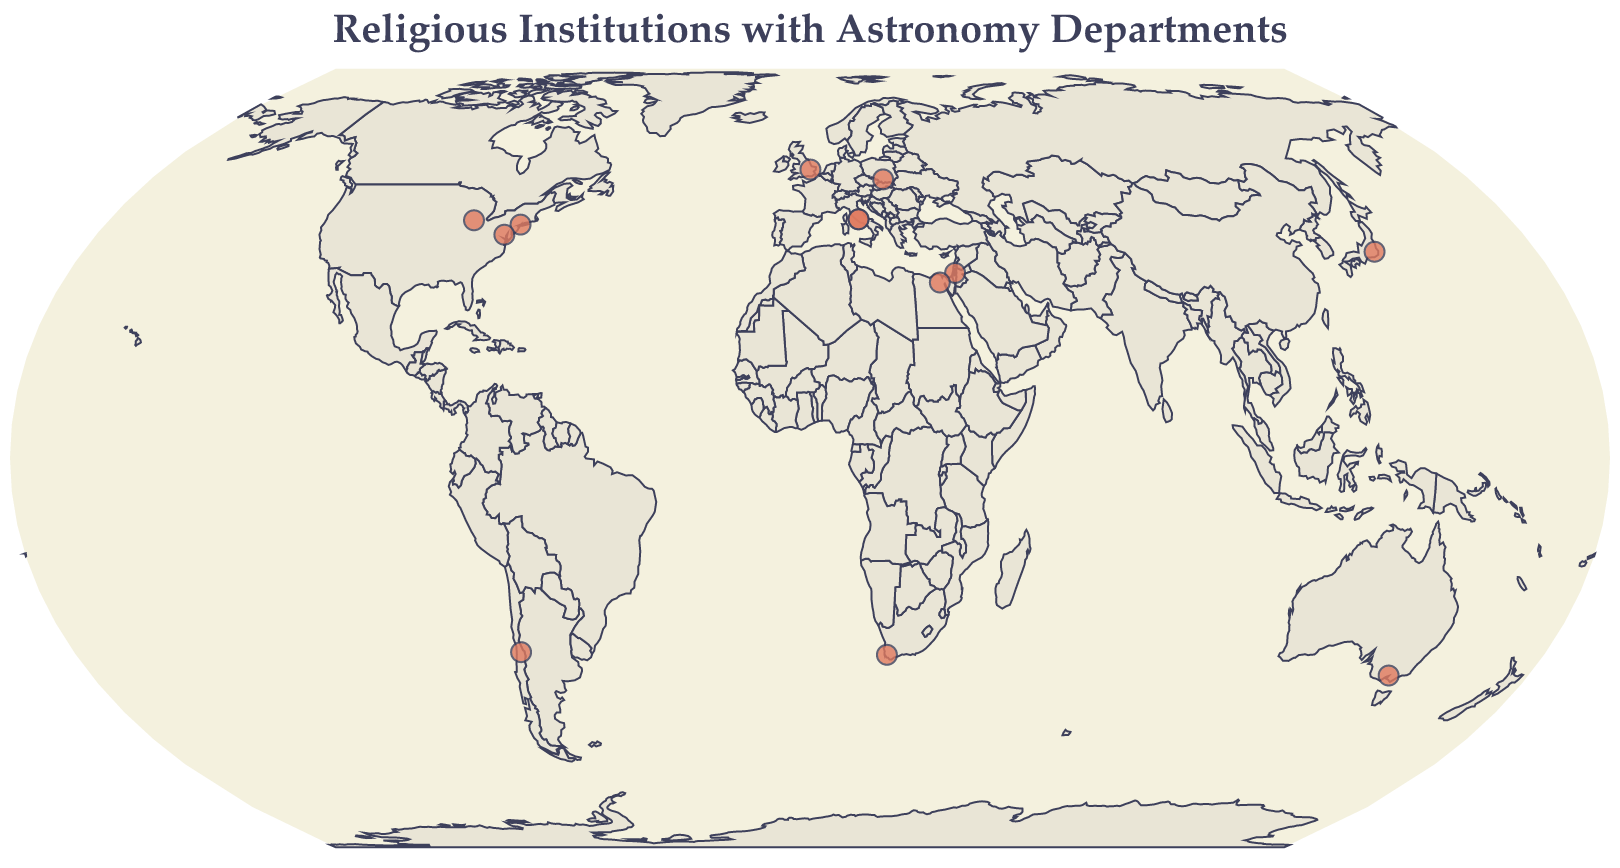What is the title of the figure? The title is usually placed at the top of the figure and provides a brief description of what the visualization represents.
Answer: Religious Institutions with Astronomy Departments How many religious institutions with astronomy departments are marked on the figure? You can count the number of circles plotted on the map, each representing a religious institution with an astronomy department.
Answer: 13 Which religious institution is located closest to the equator? By comparing the latitude values of each institution, the one with the latitude closest to 0 is nearest to the equator.
Answer: Pontifical Catholic University of Chile Which countries have more than one religious institution with astronomy departments? Look at the countries mentioned in the tooltip data. The USA has more than one institution.
Answer: USA Which religious institution is marked with the westernmost longitude? The institution with the lowest longitude value is the westernmost.
Answer: University of Notre Dame What is the average latitude of the religious institutions listed? Sum all the latitude values provided and divide by the number of institutions (13).
Answer: (41.9029+41.7056-33.4489+50.0647+31.7784+30.0444-33.9328+35.6895-37.8136+40.8616+41.8992+52.2054+38.9076)/13 ≈ 22.26 Compare the number of religious institutions in the Northern Hemisphere to those in the Southern Hemisphere. Which has more? Separate the institutions by their latitude values: positive for Northern Hemisphere and negative for Southern Hemisphere, then count and compare.
Answer: Northern Hemisphere Which religious institution is located in Australia? By referring to the tooltip information, identify the institution marked in Australia.
Answer: Australian Catholic University What color and shape are used to mark the locations of religious institutions on the map? By observing the figure, describe the primary visual characteristics used to represent the institutions.
Answer: Red circles What is the latitude and longitude of the Hebrew University of Jerusalem? By referring to the tooltip that appears when the associated mark is highlighted, you can find this data.
Answer: Latitude: 31.7784, Longitude: 35.196 